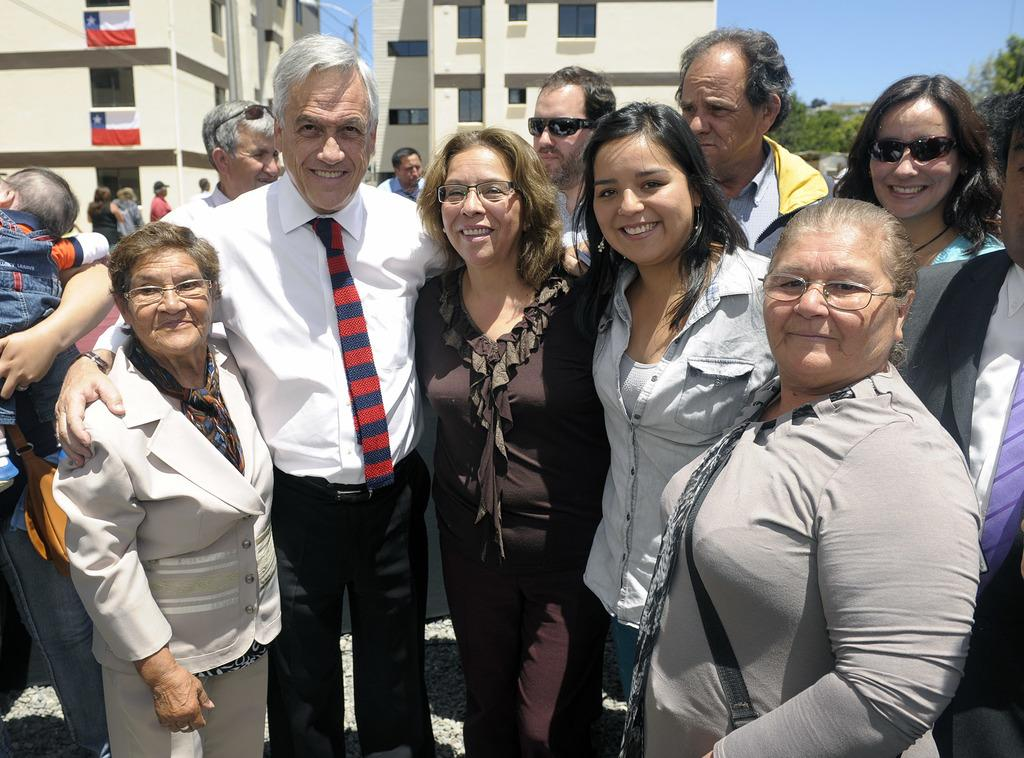How many groups of people can be seen in the image? There are groups of people in the image. What are the people in the image doing? The people are standing and smiling. What can be seen in the background of the image? There are buildings, trees, and the sky visible in the background of the image. What type of coat is the rat wearing in the image? There is no rat or coat present in the image. 